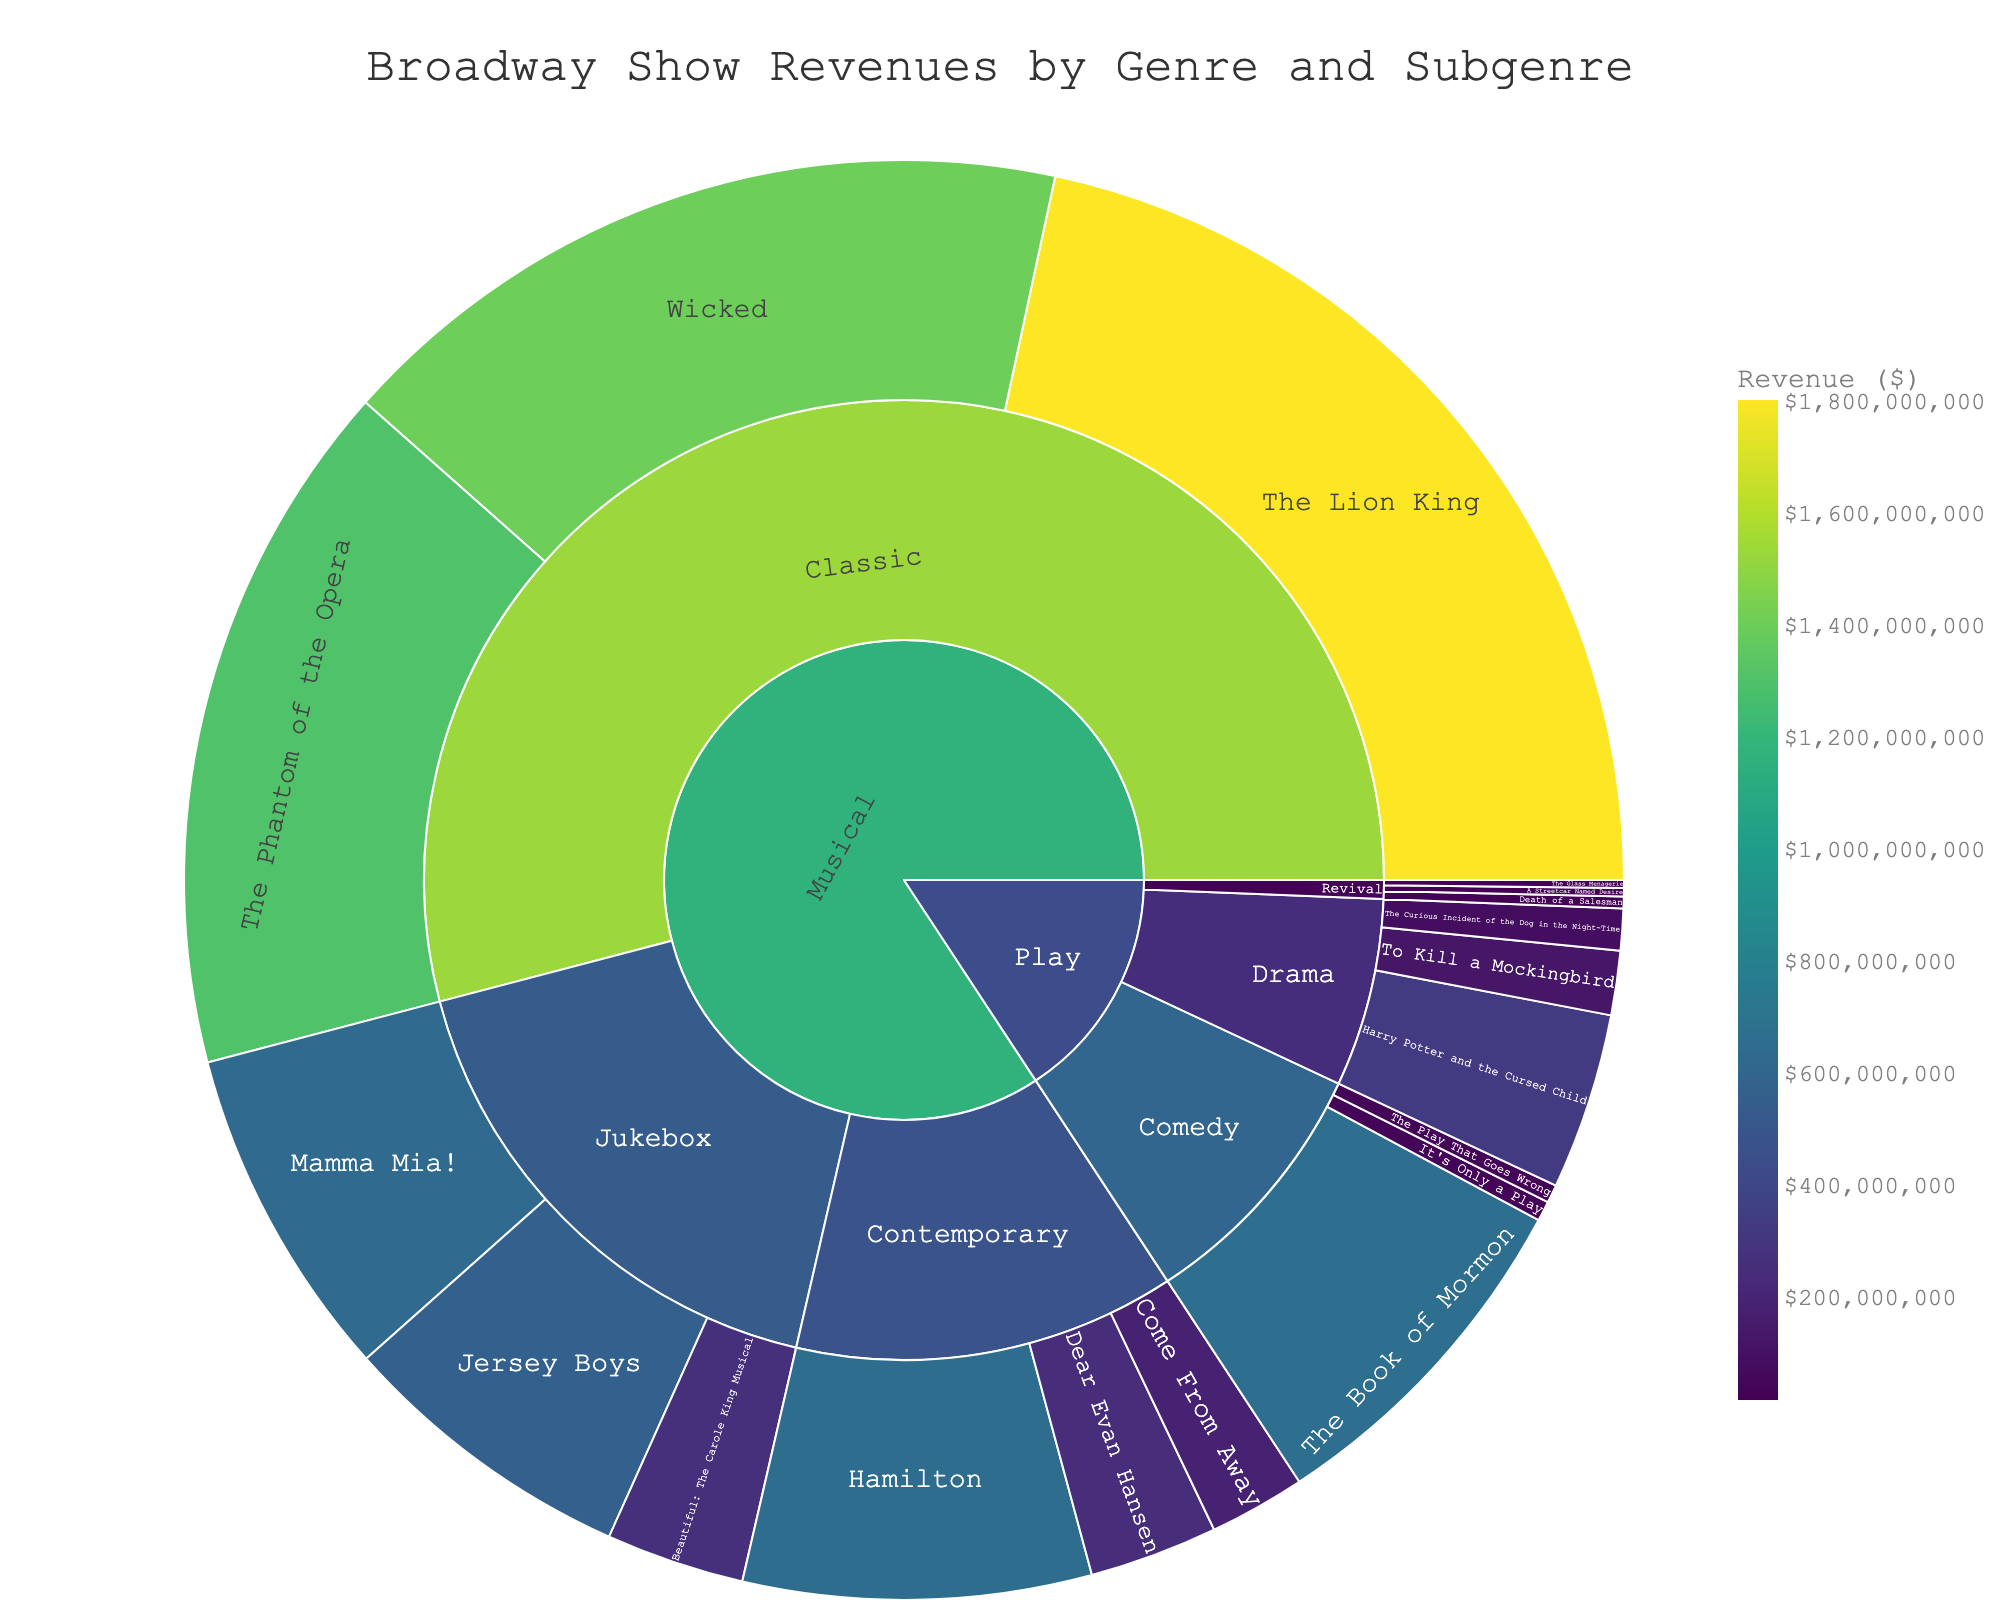what’s the title of the figure? The title of the figure is displayed at the top center. It reads "Broadway Show Revenues by Genre and Subgenre".
Answer: Broadway Show Revenues by Genre and Subgenre What genre and subgenre does "Hamilton" belong to, and what is its revenue? "Hamilton" belongs to the "Musical" genre and the "Contemporary" subgenre. Its revenue is shown on the colored section associated with it.
Answer: Musical, Contemporary, $650,000,000 Which show has the highest revenue and how much is it? The show with the highest revenue is easily identified by the largest segment in the sunburst plot. This show is "The Lion King" under the "Musical" genre and "Classic" subgenre, with a revenue of $1,800,000,000.
Answer: The Lion King, $1,800,000,000 Compare the total revenue of Contemporary Musicals to that of Jukebox Musicals. Which one is higher? Add the revenues of all the shows under each subgenre. For Contemporary Musicals, sum revenue of "Hamilton", "Dear Evan Hansen", and "Come From Away". For Jukebox Musicals, sum revenue of "Mamma Mia!", "Jersey Boys", and "Beautiful: The Carole King Musical". Compare the two sums.
Answer: Contemporary Musicals are higher How does the revenue of "The Book of Mormon" compare to "Dear Evan Hansen"? Find and compare the segments of these two shows based on their respective revenues. "The Book of Mormon" has a higher revenue than "Dear Evan Hansen".
Answer: The Book of Mormon is greater Identify the subgenre with the smallest total revenue and name the shows within it. Look for the smallest section in the plot and add up the revenues of all shows within each subgenre. "Revival" within "Play" has the smallest total revenue, with shows "Death of a Salesman", "The Glass Menagerie", and "A Streetcar Named Desire".
Answer: Revival; Death of a Salesman, The Glass Menagerie, A Streetcar Named Desire What is the combined revenue of all "Play" genre shows? Sum the revenues of all the shows under the "Play" genre, including Drama, Comedy, and Revival subgenres. Add the revenue of each show within these subgenres for the total.
Answer: $1,264,000,000 Is "The Play That Goes Wrong" a Musical or a Play, and what is its revenue? Locate the show in the plot to identify its genre, and refer to its segment for the revenue. "The Play That Goes Wrong" is a Play in the Comedy subgenre with a revenue of $34,000,000.
Answer: Play, $34,000,000 Which genre has more subgenres, Musical or Play? Count the number of different subgenres for each genre visible in the plot. The Musical genre contains Contemporary, Classic, and Jukebox (three subgenres). The Play genre contains Drama, Comedy, and Revival (three subgenres). Both have equal numbers.
Answer: Both are equal Which show in the Classic Musical subgenre has the second highest revenue? Compare the revenue segments for all shows within the Classic Musical subgenre. "The Phantom of the Opera" has the second highest revenue after "The Lion King".
Answer: The Phantom of the Opera 